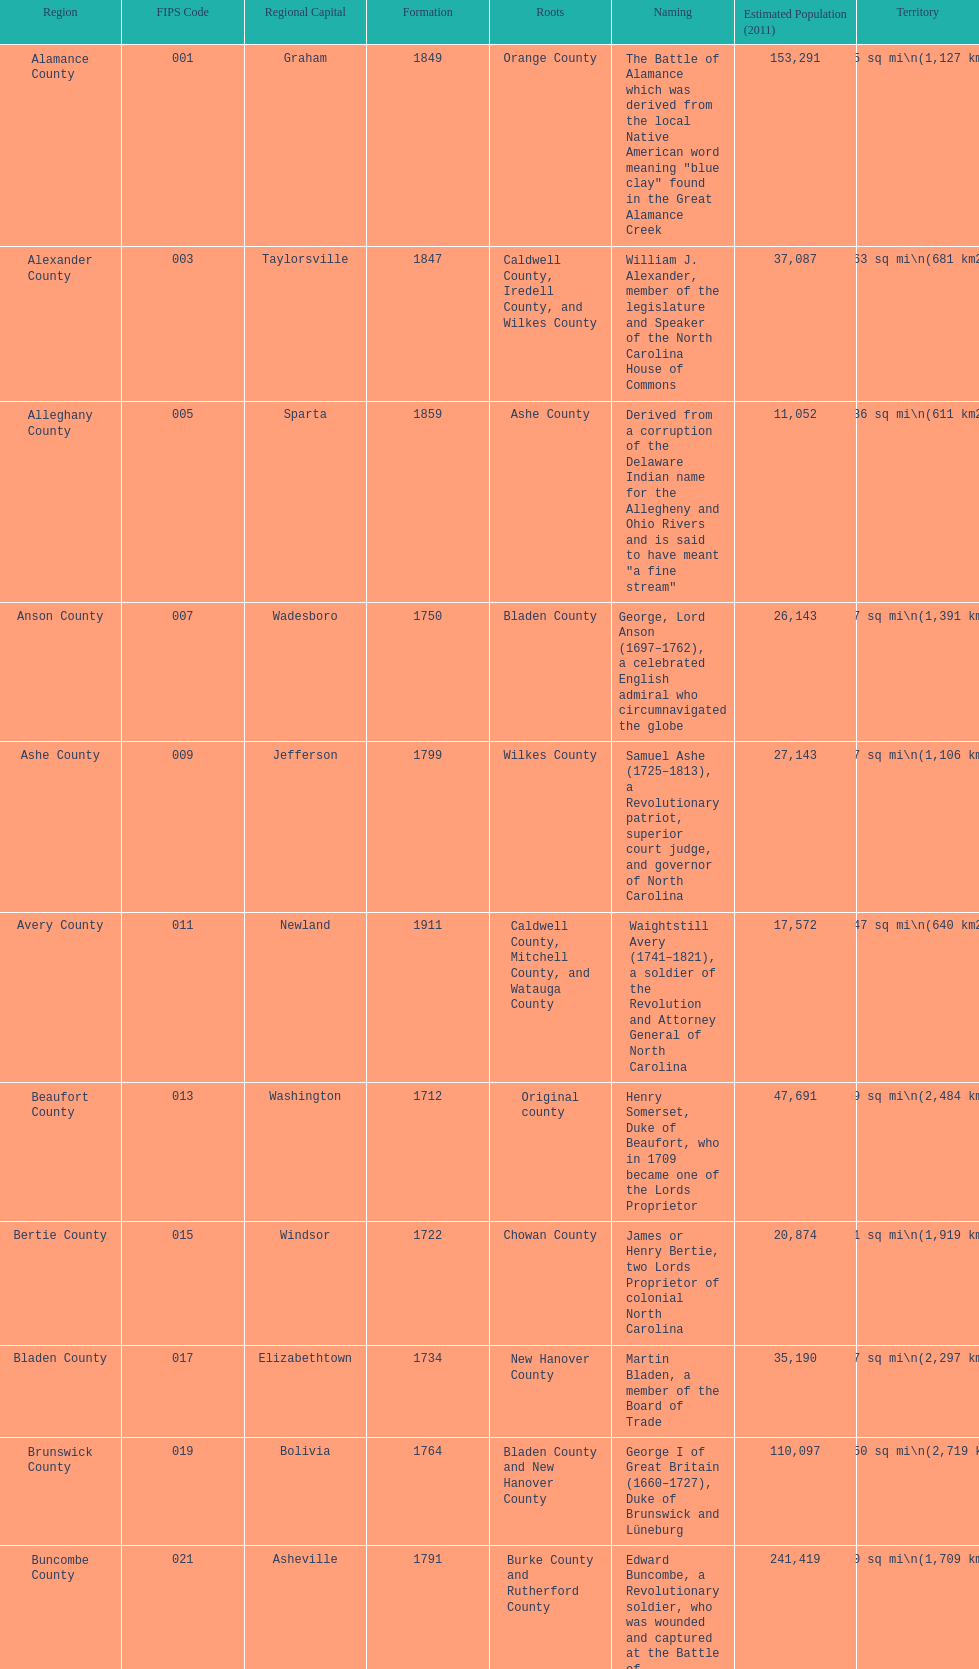Which county encompasses the largest area? Dare County. 